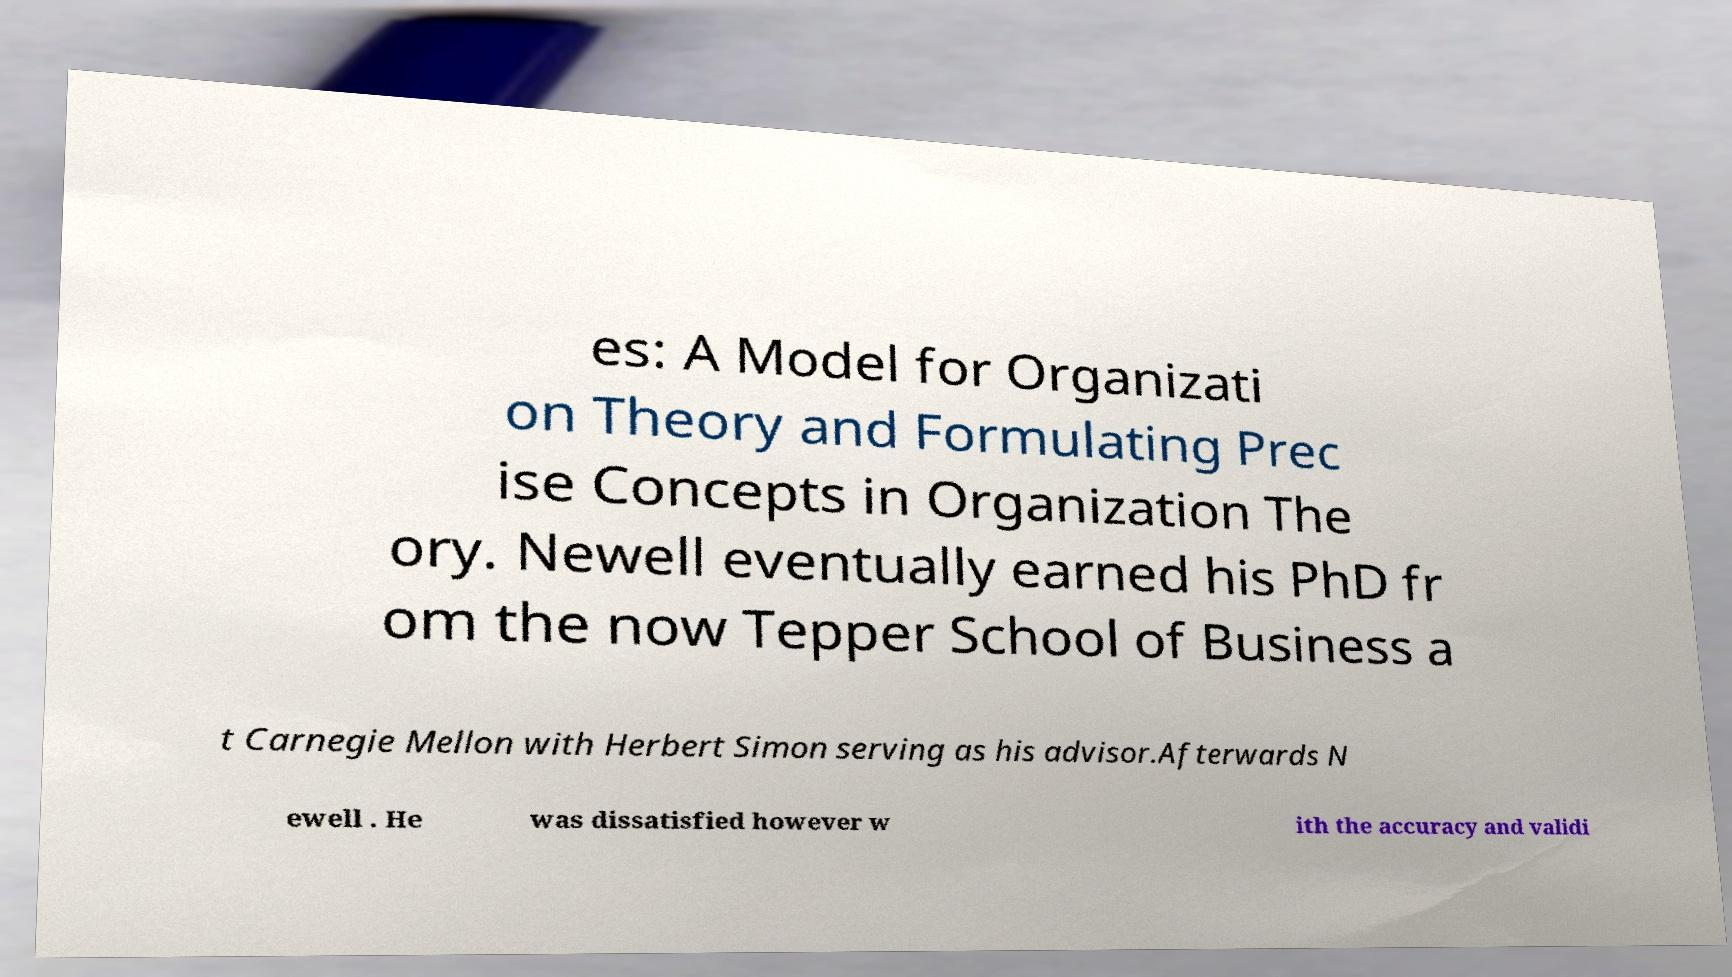Please read and relay the text visible in this image. What does it say? es: A Model for Organizati on Theory and Formulating Prec ise Concepts in Organization The ory. Newell eventually earned his PhD fr om the now Tepper School of Business a t Carnegie Mellon with Herbert Simon serving as his advisor.Afterwards N ewell . He was dissatisfied however w ith the accuracy and validi 